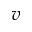<formula> <loc_0><loc_0><loc_500><loc_500>v</formula> 